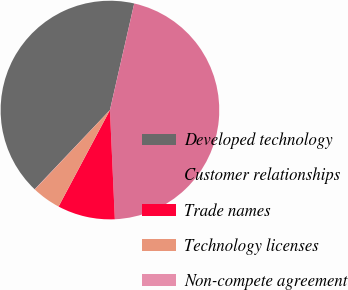Convert chart. <chart><loc_0><loc_0><loc_500><loc_500><pie_chart><fcel>Developed technology<fcel>Customer relationships<fcel>Trade names<fcel>Technology licenses<fcel>Non-compete agreement<nl><fcel>41.48%<fcel>45.72%<fcel>8.5%<fcel>4.27%<fcel>0.03%<nl></chart> 